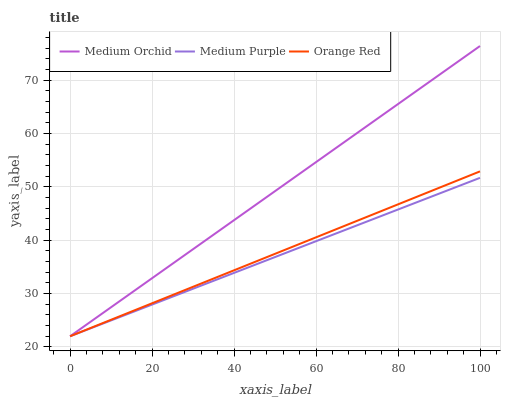Does Medium Purple have the minimum area under the curve?
Answer yes or no. Yes. Does Medium Orchid have the maximum area under the curve?
Answer yes or no. Yes. Does Orange Red have the minimum area under the curve?
Answer yes or no. No. Does Orange Red have the maximum area under the curve?
Answer yes or no. No. Is Medium Orchid the smoothest?
Answer yes or no. Yes. Is Orange Red the roughest?
Answer yes or no. Yes. Is Orange Red the smoothest?
Answer yes or no. No. Is Medium Orchid the roughest?
Answer yes or no. No. Does Medium Purple have the lowest value?
Answer yes or no. Yes. Does Medium Orchid have the highest value?
Answer yes or no. Yes. Does Orange Red have the highest value?
Answer yes or no. No. Does Medium Purple intersect Medium Orchid?
Answer yes or no. Yes. Is Medium Purple less than Medium Orchid?
Answer yes or no. No. Is Medium Purple greater than Medium Orchid?
Answer yes or no. No. 